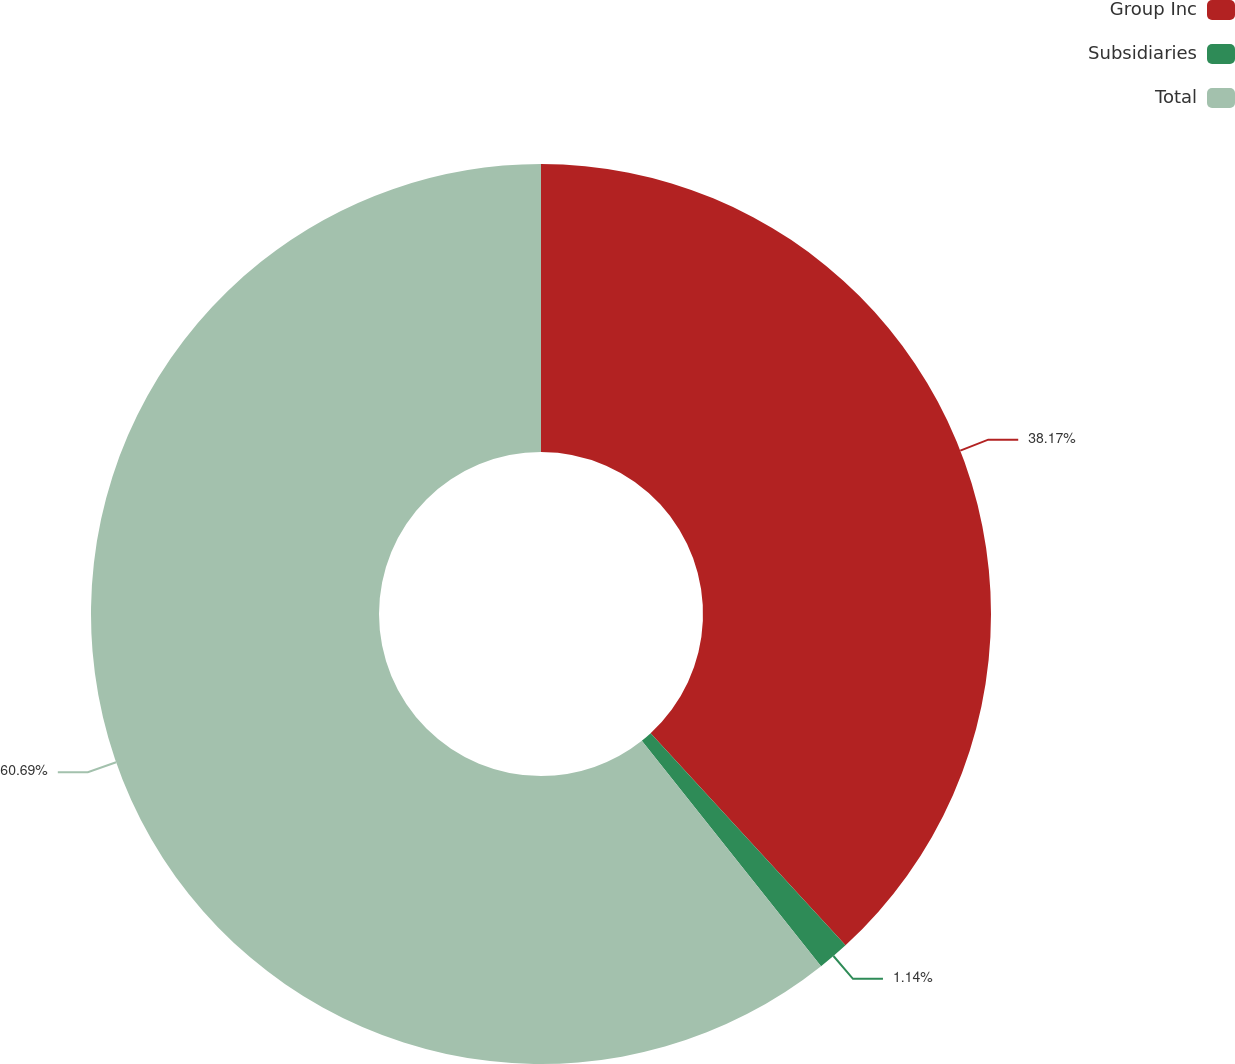Convert chart. <chart><loc_0><loc_0><loc_500><loc_500><pie_chart><fcel>Group Inc<fcel>Subsidiaries<fcel>Total<nl><fcel>38.17%<fcel>1.14%<fcel>60.69%<nl></chart> 